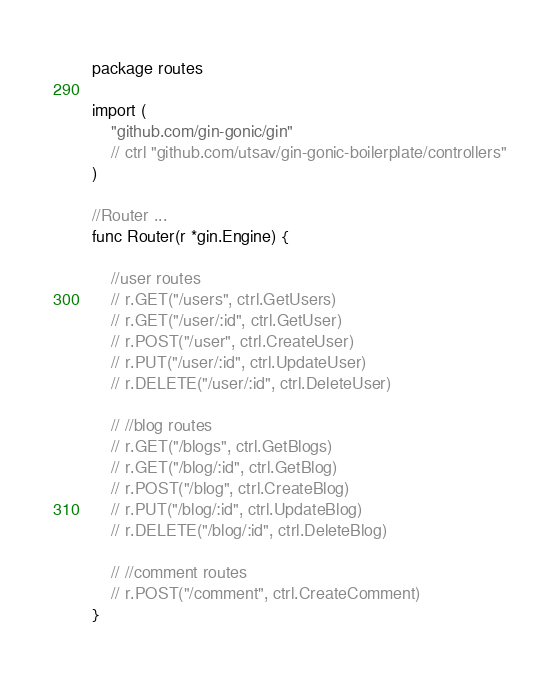Convert code to text. <code><loc_0><loc_0><loc_500><loc_500><_Go_>package routes

import (
	"github.com/gin-gonic/gin"
	// ctrl "github.com/utsav/gin-gonic-boilerplate/controllers"
)

//Router ...
func Router(r *gin.Engine) {

	//user routes
	// r.GET("/users", ctrl.GetUsers)
	// r.GET("/user/:id", ctrl.GetUser)
	// r.POST("/user", ctrl.CreateUser)
	// r.PUT("/user/:id", ctrl.UpdateUser)
	// r.DELETE("/user/:id", ctrl.DeleteUser)

	// //blog routes
	// r.GET("/blogs", ctrl.GetBlogs)
	// r.GET("/blog/:id", ctrl.GetBlog)
	// r.POST("/blog", ctrl.CreateBlog)
	// r.PUT("/blog/:id", ctrl.UpdateBlog)
	// r.DELETE("/blog/:id", ctrl.DeleteBlog)

	// //comment routes
	// r.POST("/comment", ctrl.CreateComment)
}
</code> 